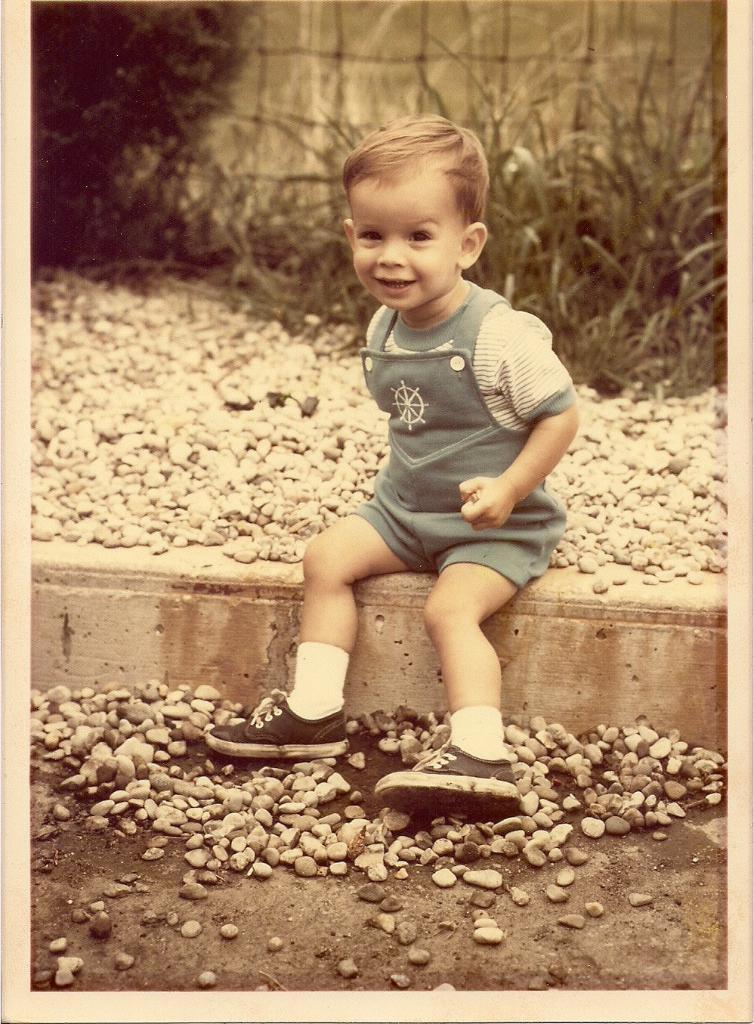What can be seen in the front of the image? There are stones in the front of the image. What is the main subject in the center of the image? There is a boy sitting in the center of the image. What is the boy's expression in the image? The boy is smiling. What type of vegetation is visible in the background of the image? There are plants in the background of the image. What color is the boy's hair in the image? The provided facts do not mention the boy's hair color, so we cannot determine the color of his hair from the image. Is there any sleet visible in the image? There is no mention of sleet in the provided facts, and it is not visible in the image. 